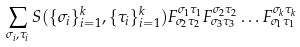Convert formula to latex. <formula><loc_0><loc_0><loc_500><loc_500>\sum _ { \sigma _ { i } , \tau _ { i } } S ( \{ \sigma _ { i } \} _ { i = 1 } ^ { k } , \{ \tau _ { i } \} _ { i = 1 } ^ { k } ) F ^ { \sigma _ { 1 } \tau _ { 1 } } _ { \sigma _ { 2 } \tau _ { 2 } } F ^ { \sigma _ { 2 } \tau _ { 2 } } _ { \sigma _ { 3 } \tau _ { 3 } } \dots F ^ { \sigma _ { k } \tau _ { k } } _ { \sigma _ { 1 } \tau _ { 1 } }</formula> 